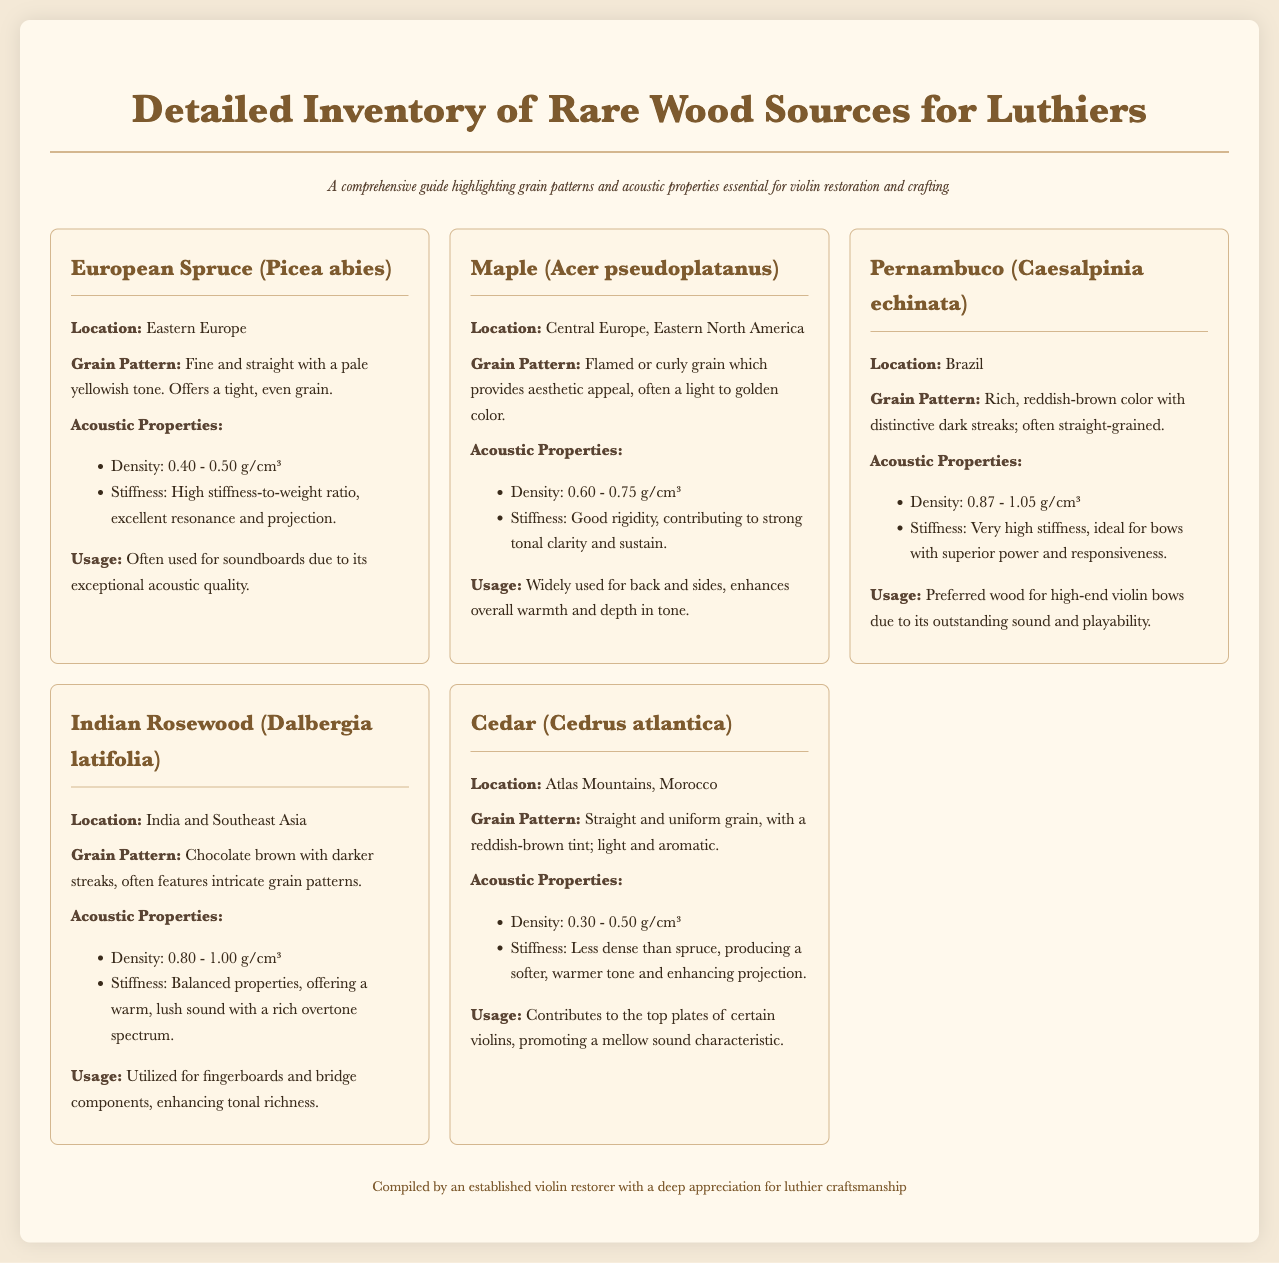What is the main focus of the catalog? The catalog emphasizes the grain patterns and acoustic properties of rare wood sources for luthiers, especially in relation to violin restoration and crafting.
Answer: Grain patterns and acoustic properties Where is European Spruce sourced from? The document specifies that European Spruce is sourced from Eastern Europe.
Answer: Eastern Europe What is the density range of Maple? The density range for Maple is provided within the acoustic properties section of the document, which states it is 0.60 - 0.75 g/cm³.
Answer: 0.60 - 0.75 g/cm³ Which wood is preferred for high-end violin bows? The document indicates that Pernambuco is preferred for high-end violin bows due to its outstanding sound and playability.
Answer: Pernambuco What color is the grain pattern of Indian Rosewood? According to the document, the grain pattern of Indian Rosewood is chocolate brown with darker streaks.
Answer: Chocolate brown What is the stiffness characteristic of Cedar? Cedar is indicated to have less density compared to spruce, producing a softer tone, which relates to its stiffness properties mentioned in the document.
Answer: Softer, warmer tone Why is Maple used for the back and sides of violins? The document states that Maple enhances overall warmth and depth in tone, making it a preferred choice for violin construction.
Answer: Enhances overall warmth and depth in tone What is the unique feature of the grain pattern of Pernambuco? The grain pattern of Pernambuco is characterized by a rich, reddish-brown color with distinctive dark streaks.
Answer: Rich, reddish-brown color with dark streaks Where does Cedar grow? The document indicates that Cedar is sourced from the Atlas Mountains in Morocco.
Answer: Atlas Mountains, Morocco 